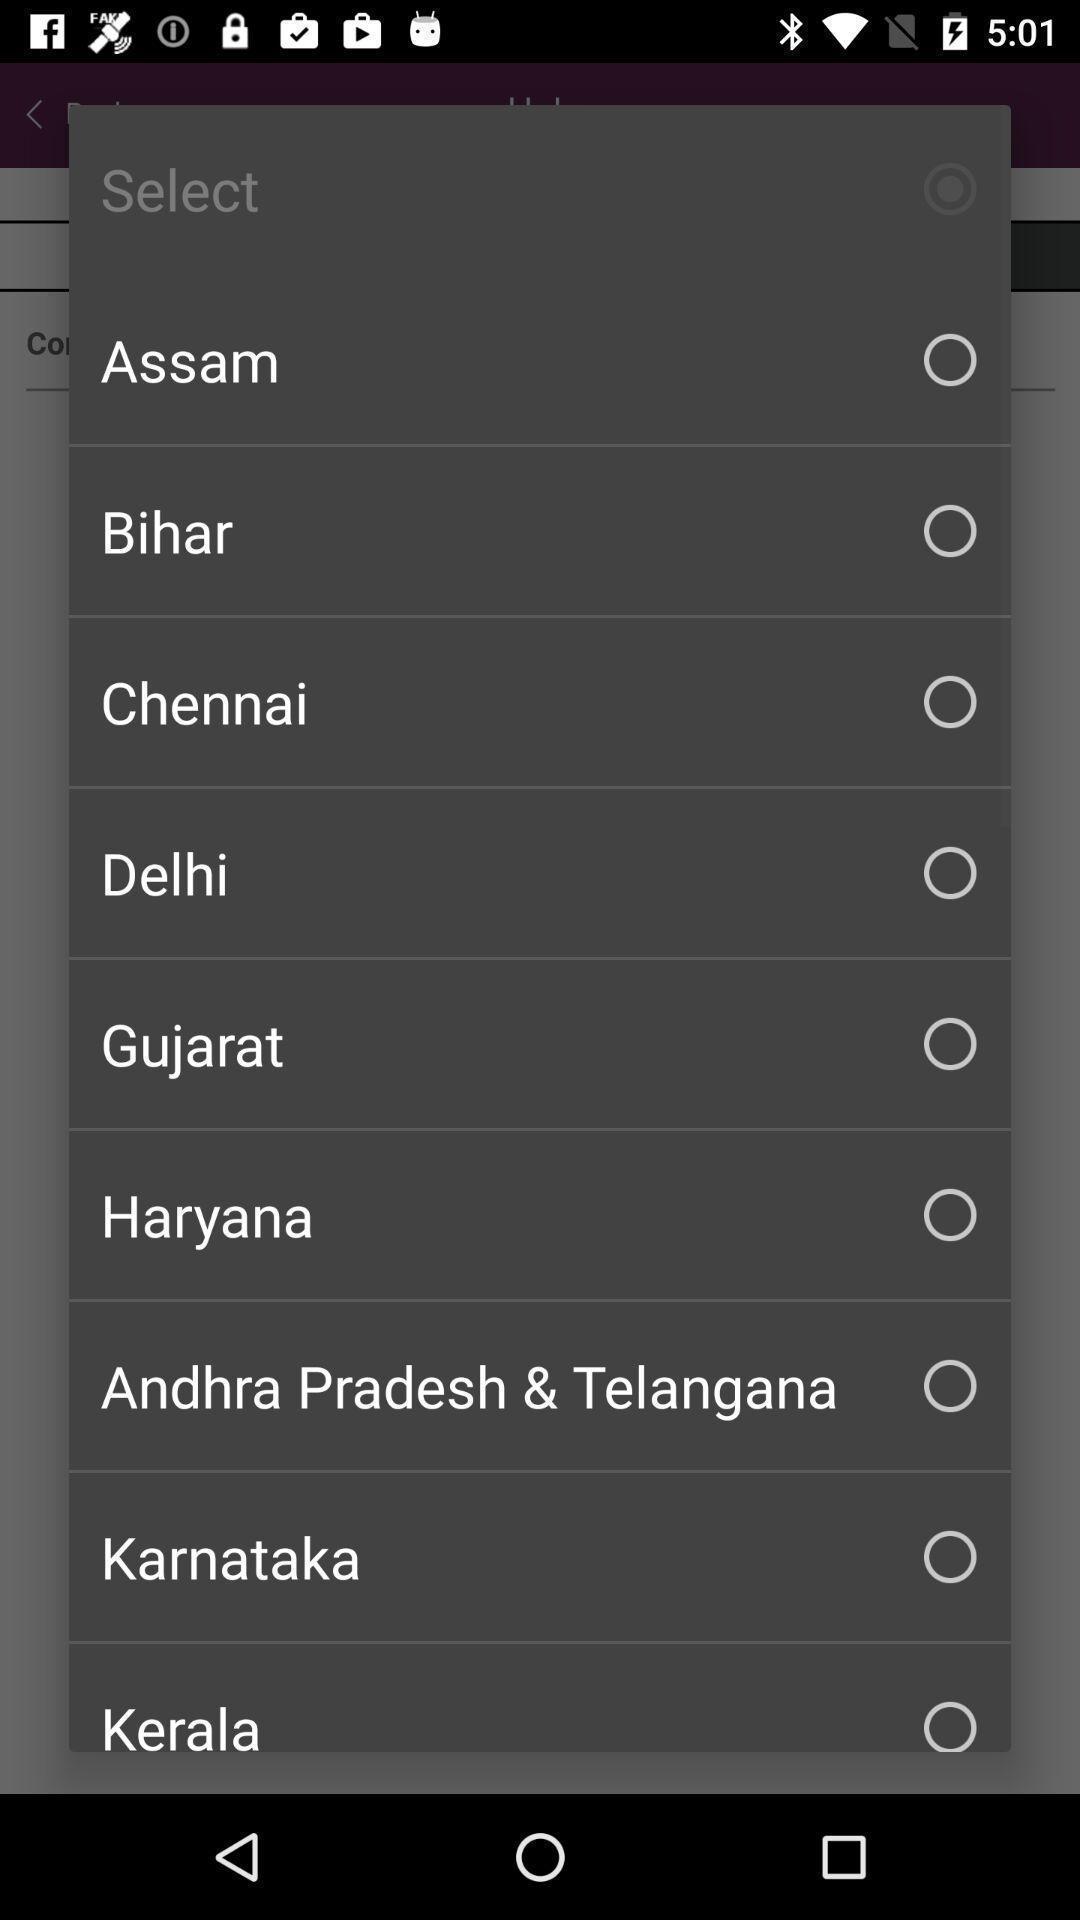Tell me what you see in this picture. Pop-up window is showing list of state names to select. 